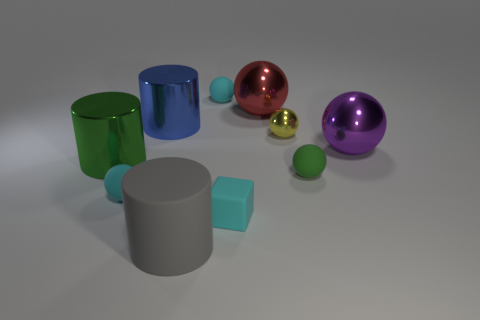Subtract all green spheres. How many spheres are left? 5 Subtract all gray cylinders. How many cylinders are left? 2 Subtract all cylinders. How many objects are left? 7 Subtract all gray cylinders. How many yellow balls are left? 1 Subtract all large rubber objects. Subtract all tiny yellow cubes. How many objects are left? 9 Add 2 blue objects. How many blue objects are left? 3 Add 1 small gray blocks. How many small gray blocks exist? 1 Subtract 0 yellow cylinders. How many objects are left? 10 Subtract all red cylinders. Subtract all red cubes. How many cylinders are left? 3 